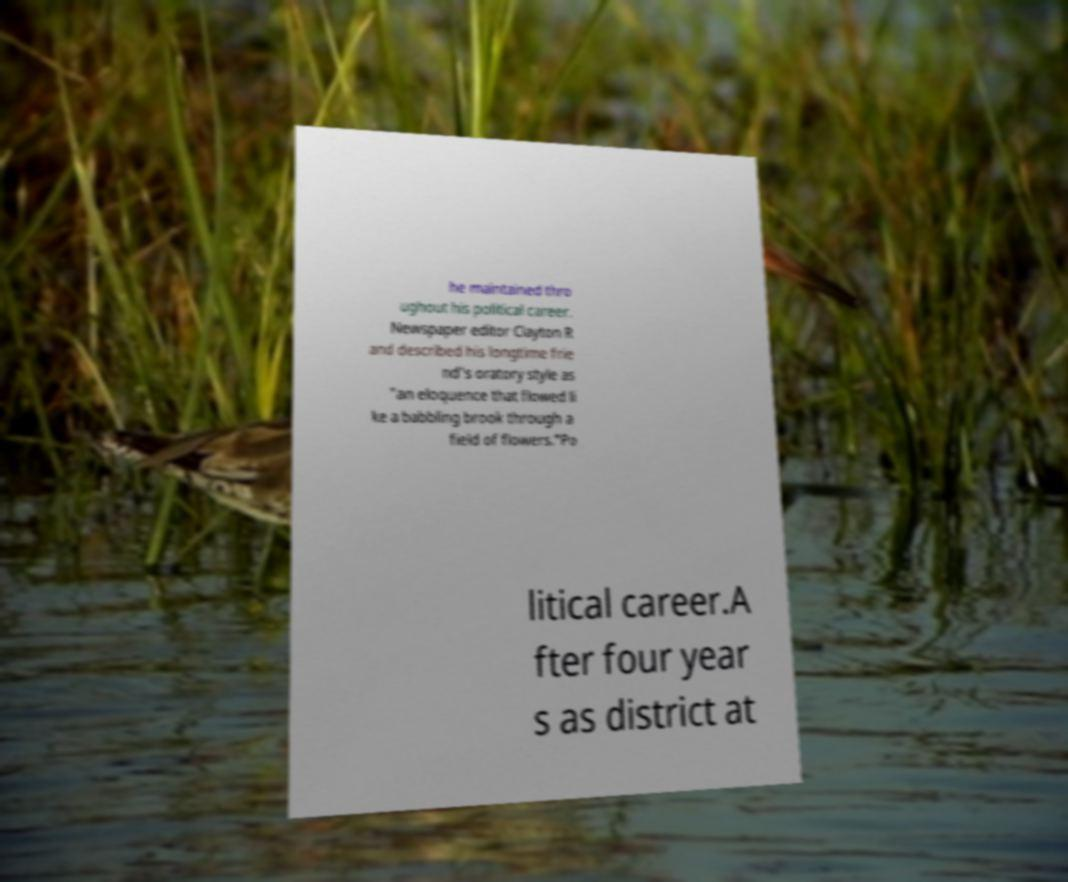Can you accurately transcribe the text from the provided image for me? he maintained thro ughout his political career. Newspaper editor Clayton R and described his longtime frie nd's oratory style as "an eloquence that flowed li ke a babbling brook through a field of flowers."Po litical career.A fter four year s as district at 